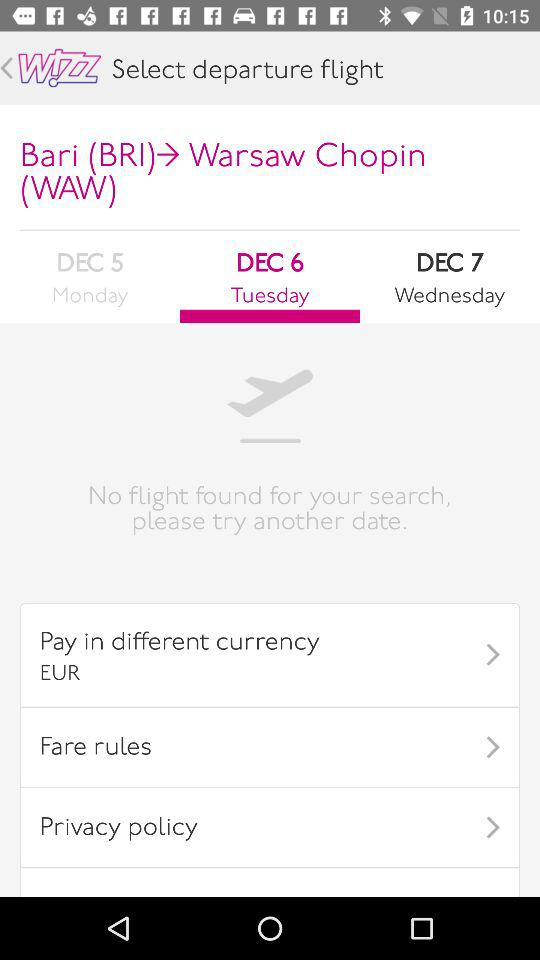How many days are available for flights?
Answer the question using a single word or phrase. 3 